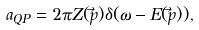Convert formula to latex. <formula><loc_0><loc_0><loc_500><loc_500>a _ { Q P } = 2 \pi Z ( \vec { p } ) \delta ( \omega - E ( \vec { p } ) ) ,</formula> 